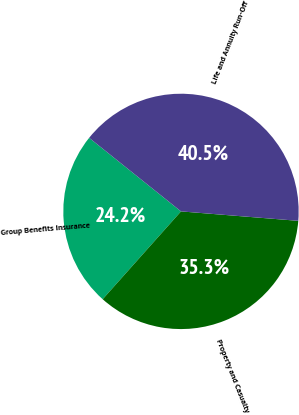Convert chart. <chart><loc_0><loc_0><loc_500><loc_500><pie_chart><fcel>Group Benefits Insurance<fcel>Property and Casualty<fcel>Life and Annuity Run-Off<nl><fcel>24.16%<fcel>35.31%<fcel>40.53%<nl></chart> 